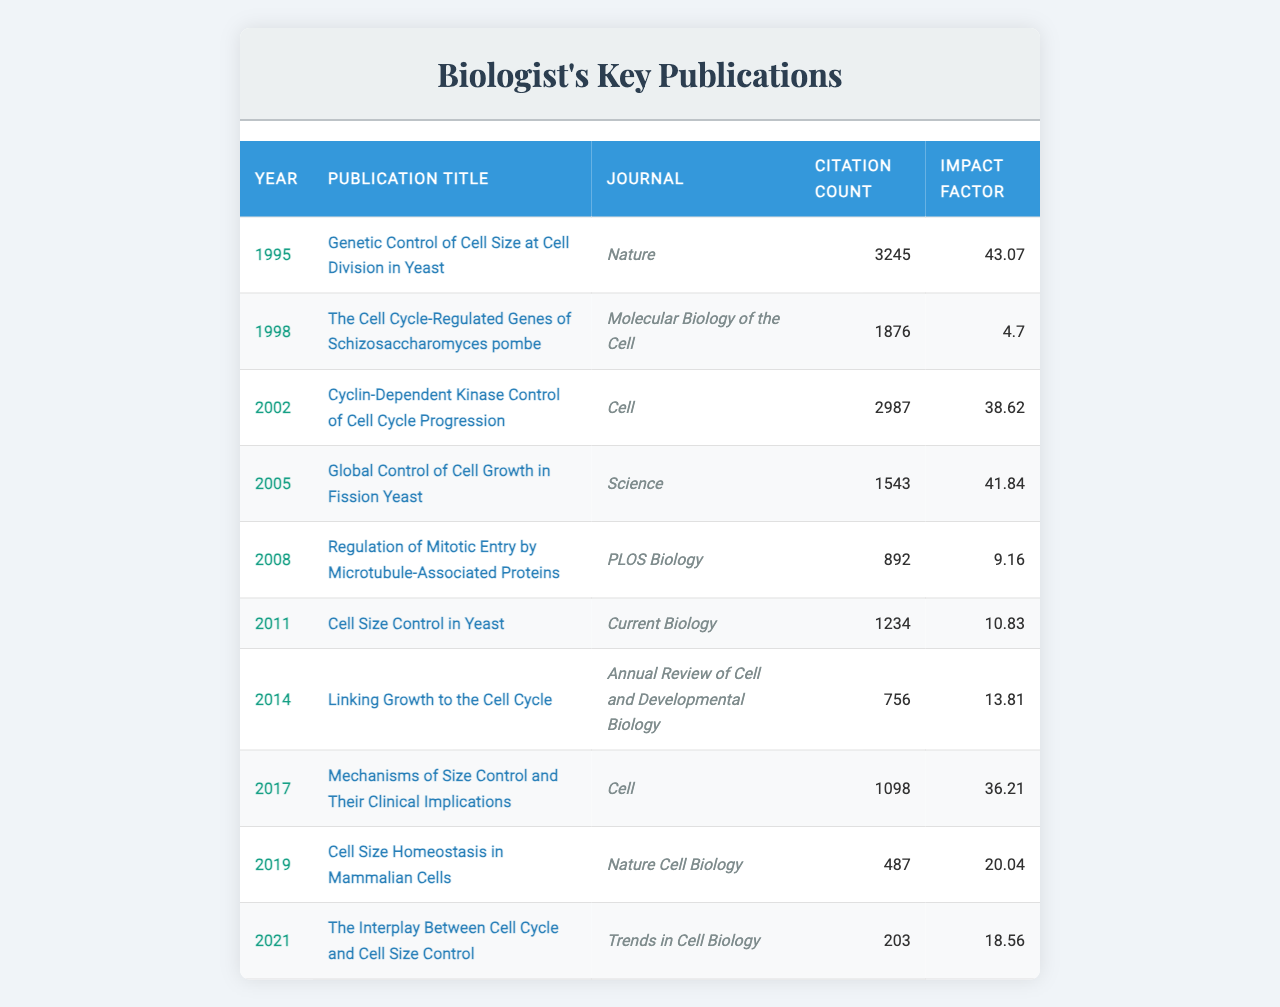What is the title of the publication with the highest citation count? The table lists the citation counts for each publication. The highest citation count is 3245, which corresponds to the publication titled "Genetic Control of Cell Size at Cell Division in Yeast."
Answer: "Genetic Control of Cell Size at Cell Division in Yeast" In which year was the paper "Linking Growth to the Cell Cycle" published? The title "Linking Growth to the Cell Cycle" is found in the table under the Year column, which shows it was published in 2014.
Answer: 2014 What is the impact factor of the publication titled "Molecular Biology of the Cell"? The table shows the impact factor for "The Cell Cycle-Regulated Genes of Schizosaccharomyces pombe" (published in 1998) as 4.7, which corresponds to the journal "Molecular Biology of the Cell."
Answer: 4.7 What is the average citation count for the publications listed? The citation counts are: 3245, 1876, 2987, 1543, 892, 1234, 756, 1098, 487, and 203. Summing these gives 11958. There are 10 publications, so the average citation count is 11958 / 10 = 1195.8.
Answer: 1195.8 Was the publication with the title "Global Control of Cell Growth in Fission Yeast" cited more than 1500 times? The citation count for "Global Control of Cell Growth in Fission Yeast" is 1543. Since 1543 is greater than 1500, the answer is yes.
Answer: Yes How does the impact factor change over the years for the publications in the table? The impact factors are: 43.07 (1995), 4.7 (1998), 38.62 (2002), 41.84 (2005), 9.16 (2008), 10.83 (2011), 13.81 (2014), 36.21 (2017), 20.04 (2019), and 18.56 (2021). Analyzing these figures shows significant fluctuations, with several peaks and declines over the years.
Answer: Fluctuates with peaks and declines Which journal published the most papers in this table? By reviewing the journal column, we see that "Cell" appears twice (2002 and 2017), while others appear once. Since it's the only journal with two publications, it has the highest count.
Answer: Cell What was the total citation count for the publications in the year 2005 and later? The publication counts from 2005 onward are 1543 (2005), 892 (2008), 1234 (2011), 756 (2014), 1098 (2017), 487 (2019), and 203 (2021). Adding these gives 1543 + 892 + 1234 + 756 + 1098 + 487 + 203 = 5213.
Answer: 5213 